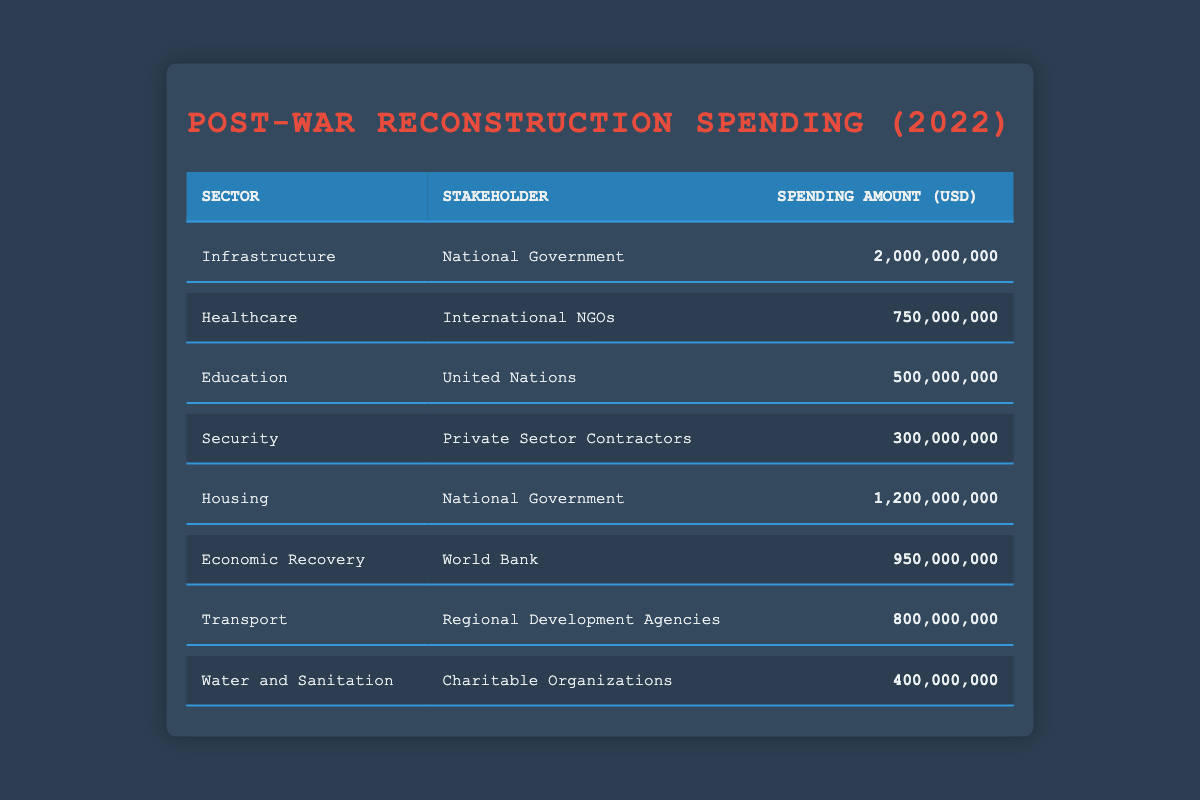What is the total spending amount for the Housing sector? The Housing sector shows a spending amount of 1,200,000,000 USD in the table. This is the only entry listed under the Housing sector, so the total is directly obtained from this value.
Answer: 1,200,000,000 USD Which stakeholder spent the most on Infrastructure? The Infrastructure sector shows that the National Government spent 2,000,000,000 USD. There is no other entry for the Infrastructure sector, which makes this amount the highest for that specific sector.
Answer: National Government What is the sum of spending amounts from the National Government across all sectors? The National Government spent 2,000,000,000 USD on Infrastructure and 1,200,000,000 USD on Housing. To calculate the total, we add these amounts: 2,000,000,000 + 1,200,000,000 = 3,200,000,000 USD.
Answer: 3,200,000,000 USD Did the Private Sector Contractors spend more than International NGOs on Healthcare? The table shows that Private Sector Contractors spent 300,000,000 USD on Security, and International NGOs spent 750,000,000 USD on Healthcare. Since 300,000,000 is less than 750,000,000, the answer is no.
Answer: No What is the average spending amount of all sectors represented in the table? To find the average, we first sum all the spending amounts: 2,000,000,000 + 750,000,000 + 500,000,000 + 300,000,000 + 1,200,000,000 + 950,000,000 + 800,000,000 + 400,000,000 = 6,950,000,000 USD. Then, we divide this by the number of sectors, which is 8: 6,950,000,000 / 8 = 868,750,000 USD.
Answer: 868,750,000 USD Which sector received the least funding, and how much was it? Looking at the spending amounts, the smallest value is 300,000,000 USD spent on the Security sector by Private Sector Contractors. This indicates that the Security sector received the least funding compared to other sectors listed.
Answer: Security sector, 300,000,000 USD How much did the World Bank spend compared to the total spending by Charitable Organizations? The World Bank spent 950,000,000 USD on Economic Recovery, and Charitable Organizations spent 400,000,000 USD on Water and Sanitation. Comparing these two amounts reveals that 950,000,000 is greater than 400,000,000. Therefore, the World Bank spent more.
Answer: Yes What percentage of the total spending was allocated to Healthcare? First, we find the total spending of all sectors, which is 6,950,000,000 USD as calculated earlier. The Healthcare sector spent 750,000,000 USD. To find the percentage, we divide the Healthcare spending by the total spending: (750,000,000 / 6,950,000,000) * 100 = 10.79%.
Answer: 10.79% 